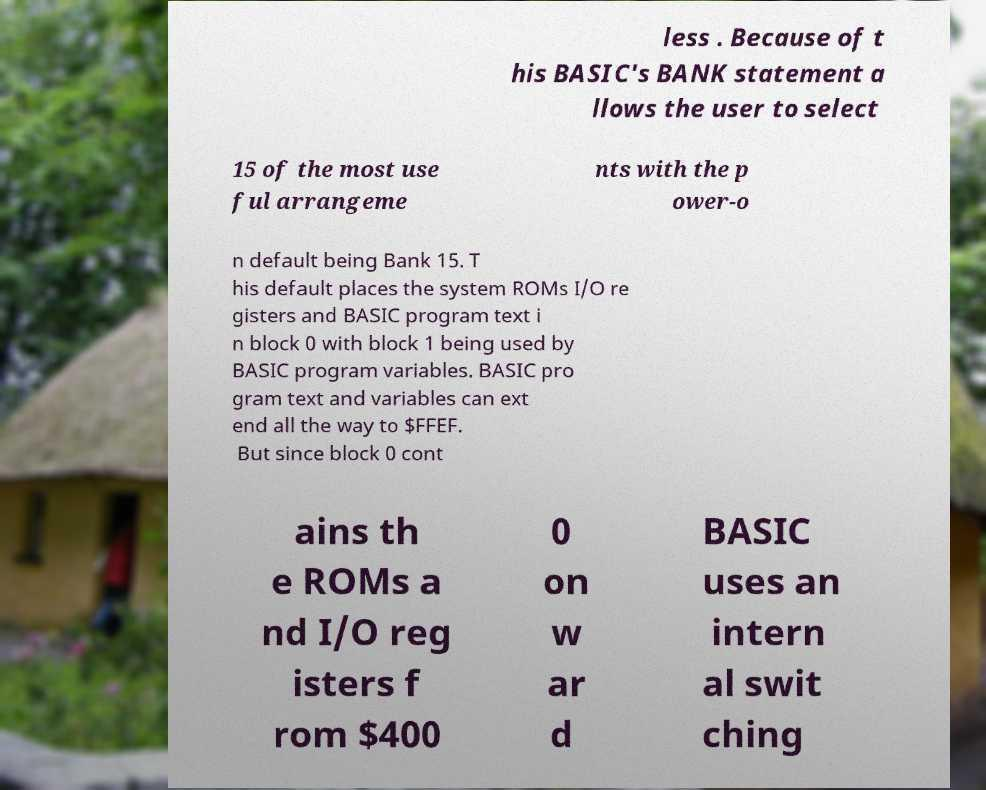Please identify and transcribe the text found in this image. less . Because of t his BASIC's BANK statement a llows the user to select 15 of the most use ful arrangeme nts with the p ower-o n default being Bank 15. T his default places the system ROMs I/O re gisters and BASIC program text i n block 0 with block 1 being used by BASIC program variables. BASIC pro gram text and variables can ext end all the way to $FFEF. But since block 0 cont ains th e ROMs a nd I/O reg isters f rom $400 0 on w ar d BASIC uses an intern al swit ching 